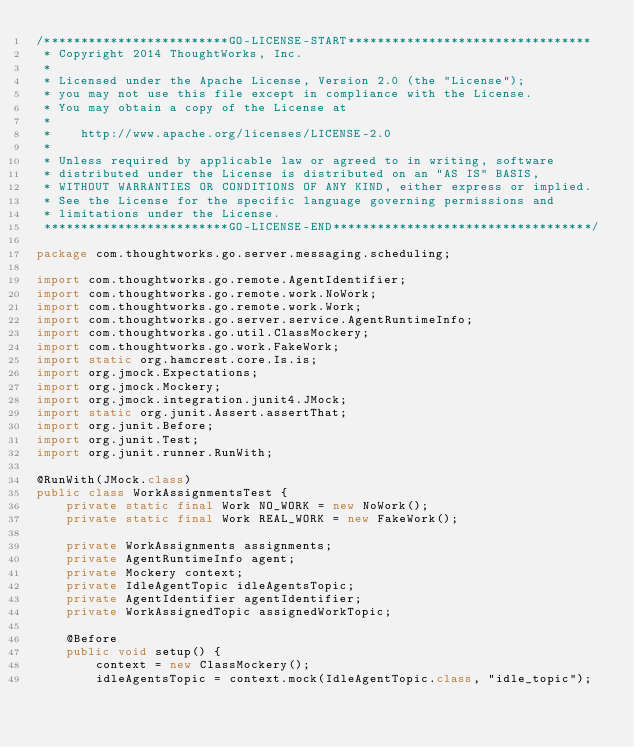<code> <loc_0><loc_0><loc_500><loc_500><_Java_>/*************************GO-LICENSE-START*********************************
 * Copyright 2014 ThoughtWorks, Inc.
 *
 * Licensed under the Apache License, Version 2.0 (the "License");
 * you may not use this file except in compliance with the License.
 * You may obtain a copy of the License at
 *
 *    http://www.apache.org/licenses/LICENSE-2.0
 *
 * Unless required by applicable law or agreed to in writing, software
 * distributed under the License is distributed on an "AS IS" BASIS,
 * WITHOUT WARRANTIES OR CONDITIONS OF ANY KIND, either express or implied.
 * See the License for the specific language governing permissions and
 * limitations under the License.
 *************************GO-LICENSE-END***********************************/

package com.thoughtworks.go.server.messaging.scheduling;

import com.thoughtworks.go.remote.AgentIdentifier;
import com.thoughtworks.go.remote.work.NoWork;
import com.thoughtworks.go.remote.work.Work;
import com.thoughtworks.go.server.service.AgentRuntimeInfo;
import com.thoughtworks.go.util.ClassMockery;
import com.thoughtworks.go.work.FakeWork;
import static org.hamcrest.core.Is.is;
import org.jmock.Expectations;
import org.jmock.Mockery;
import org.jmock.integration.junit4.JMock;
import static org.junit.Assert.assertThat;
import org.junit.Before;
import org.junit.Test;
import org.junit.runner.RunWith;

@RunWith(JMock.class)
public class WorkAssignmentsTest {
    private static final Work NO_WORK = new NoWork();
    private static final Work REAL_WORK = new FakeWork();

    private WorkAssignments assignments;
    private AgentRuntimeInfo agent;
    private Mockery context;
    private IdleAgentTopic idleAgentsTopic;
    private AgentIdentifier agentIdentifier;
    private WorkAssignedTopic assignedWorkTopic;

    @Before
    public void setup() {
        context = new ClassMockery();
        idleAgentsTopic = context.mock(IdleAgentTopic.class, "idle_topic");</code> 